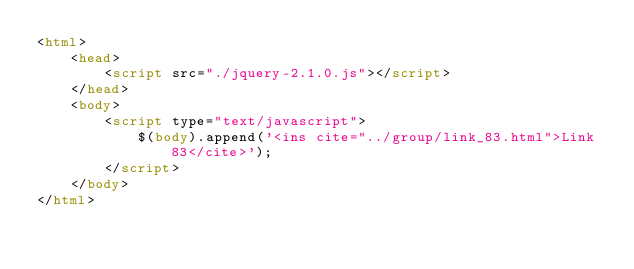<code> <loc_0><loc_0><loc_500><loc_500><_HTML_><html>
    <head>
        <script src="./jquery-2.1.0.js"></script>
    </head>
    <body>
        <script type="text/javascript">
            $(body).append('<ins cite="../group/link_83.html">Link 83</cite>');
        </script>
    </body>
</html>
</code> 